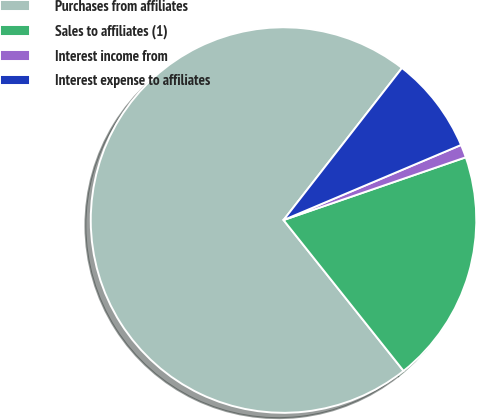<chart> <loc_0><loc_0><loc_500><loc_500><pie_chart><fcel>Purchases from affiliates<fcel>Sales to affiliates (1)<fcel>Interest income from<fcel>Interest expense to affiliates<nl><fcel>71.23%<fcel>19.58%<fcel>1.09%<fcel>8.1%<nl></chart> 